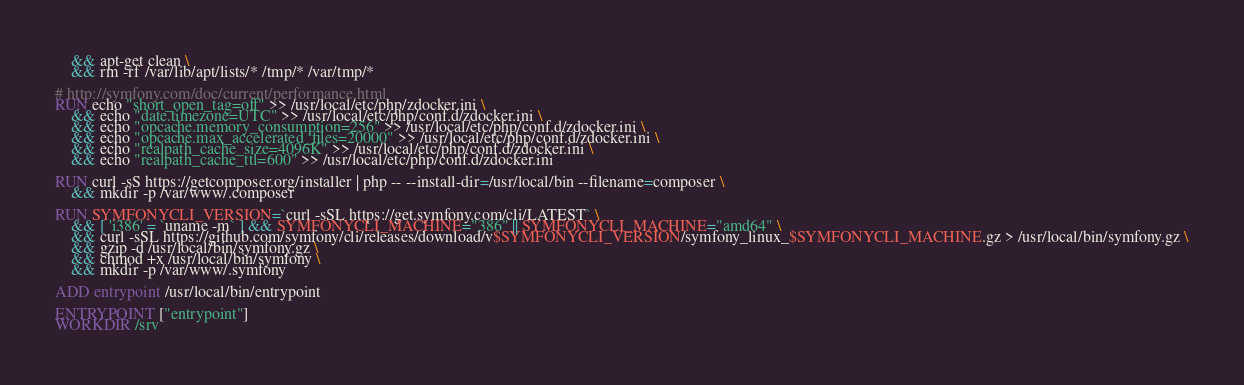Convert code to text. <code><loc_0><loc_0><loc_500><loc_500><_Dockerfile_>    && apt-get clean \
    && rm -rf /var/lib/apt/lists/* /tmp/* /var/tmp/*

# http://symfony.com/doc/current/performance.html
RUN echo "short_open_tag=off" >> /usr/local/etc/php/zdocker.ini \
    && echo "date.timezone=UTC" >> /usr/local/etc/php/conf.d/zdocker.ini \
    && echo "opcache.memory_consumption=256" >> /usr/local/etc/php/conf.d/zdocker.ini \
    && echo "opcache.max_accelerated_files=20000" >> /usr/local/etc/php/conf.d/zdocker.ini \
    && echo "realpath_cache_size=4096K" >> /usr/local/etc/php/conf.d/zdocker.ini \
    && echo "realpath_cache_ttl=600" >> /usr/local/etc/php/conf.d/zdocker.ini

RUN curl -sS https://getcomposer.org/installer | php -- --install-dir=/usr/local/bin --filename=composer \
    && mkdir -p /var/www/.composer

RUN SYMFONYCLI_VERSION=`curl -sSL https://get.symfony.com/cli/LATEST` \
    && [ 'i386' = `uname -m` ] && SYMFONYCLI_MACHINE="386" || SYMFONYCLI_MACHINE="amd64" \
    && curl -sSL https://github.com/symfony/cli/releases/download/v$SYMFONYCLI_VERSION/symfony_linux_$SYMFONYCLI_MACHINE.gz > /usr/local/bin/symfony.gz \
    && gzip -d /usr/local/bin/symfony.gz \
    && chmod +x /usr/local/bin/symfony \
    && mkdir -p /var/www/.symfony

ADD entrypoint /usr/local/bin/entrypoint

ENTRYPOINT ["entrypoint"]
WORKDIR /srv
</code> 